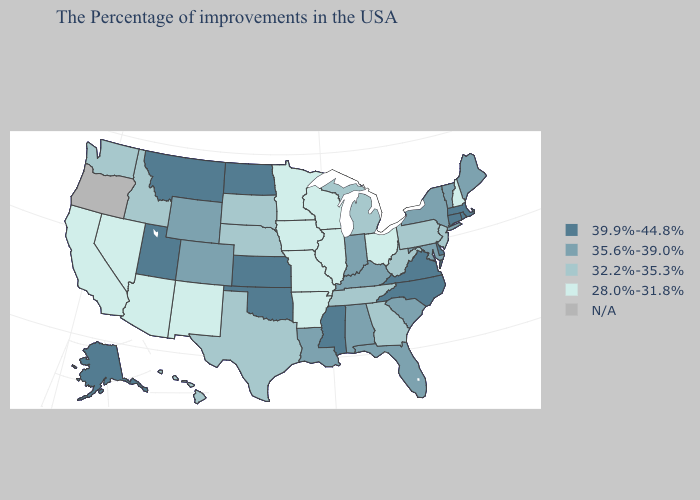Does Montana have the highest value in the West?
Short answer required. Yes. Among the states that border Maryland , does West Virginia have the highest value?
Short answer required. No. How many symbols are there in the legend?
Answer briefly. 5. What is the value of Louisiana?
Write a very short answer. 35.6%-39.0%. What is the lowest value in the USA?
Be succinct. 28.0%-31.8%. Does the map have missing data?
Short answer required. Yes. Name the states that have a value in the range 32.2%-35.3%?
Give a very brief answer. New Jersey, Pennsylvania, West Virginia, Georgia, Michigan, Tennessee, Nebraska, Texas, South Dakota, Idaho, Washington, Hawaii. Which states hav the highest value in the Northeast?
Concise answer only. Massachusetts, Rhode Island, Connecticut. Does the map have missing data?
Give a very brief answer. Yes. What is the value of New Hampshire?
Write a very short answer. 28.0%-31.8%. What is the value of Arizona?
Concise answer only. 28.0%-31.8%. What is the value of New Hampshire?
Short answer required. 28.0%-31.8%. Name the states that have a value in the range 39.9%-44.8%?
Answer briefly. Massachusetts, Rhode Island, Connecticut, Delaware, Virginia, North Carolina, Mississippi, Kansas, Oklahoma, North Dakota, Utah, Montana, Alaska. 